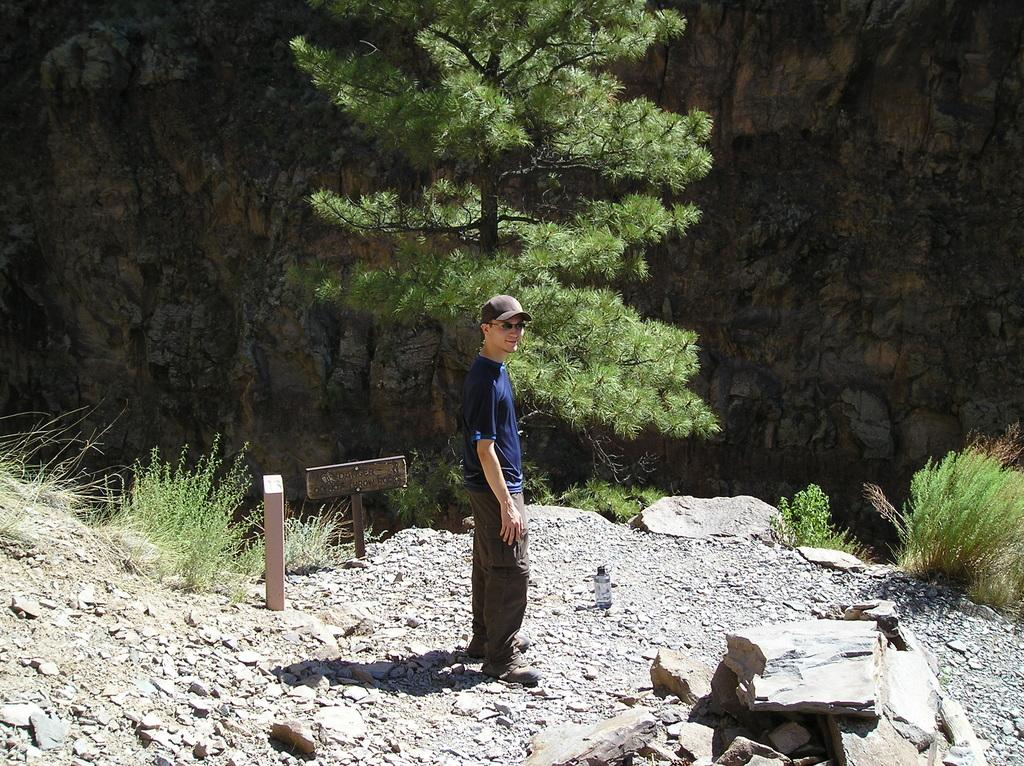What can be seen in the image? There is a person in the image. What is the person wearing on their head? The person is wearing a cap. What is the person standing on? The person is standing on rocks. What is the person's facial expression? The person has a smile on their face. What is visible in the background of the image? There are trees and rocks behind the person. What type of songs can be heard in the image? There is no sound in the image, so it is not possible to determine what songs might be heard. 